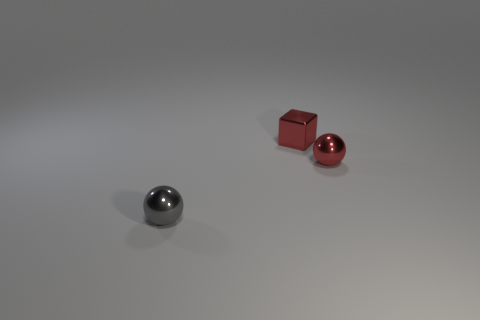There is a small shiny object to the left of the small cube; is its color the same as the tiny metal sphere that is to the right of the shiny cube?
Your response must be concise. No. How many rubber objects are either small red things or blocks?
Your answer should be compact. 0. How many tiny gray balls are in front of the small metal sphere on the left side of the tiny metal sphere on the right side of the small gray shiny ball?
Offer a very short reply. 0. The red sphere that is made of the same material as the red cube is what size?
Ensure brevity in your answer.  Small. How many things have the same color as the cube?
Provide a succinct answer. 1. There is a red thing that is in front of the metallic block; is its size the same as the tiny shiny block?
Offer a terse response. Yes. There is a tiny object that is in front of the tiny shiny cube and right of the gray sphere; what color is it?
Your answer should be very brief. Red. What number of objects are either small blocks or small metal balls that are behind the gray metallic ball?
Keep it short and to the point. 2. What is the small object that is in front of the shiny sphere behind the ball that is to the left of the block made of?
Keep it short and to the point. Metal. Is there any other thing that is made of the same material as the small red sphere?
Offer a very short reply. Yes. 